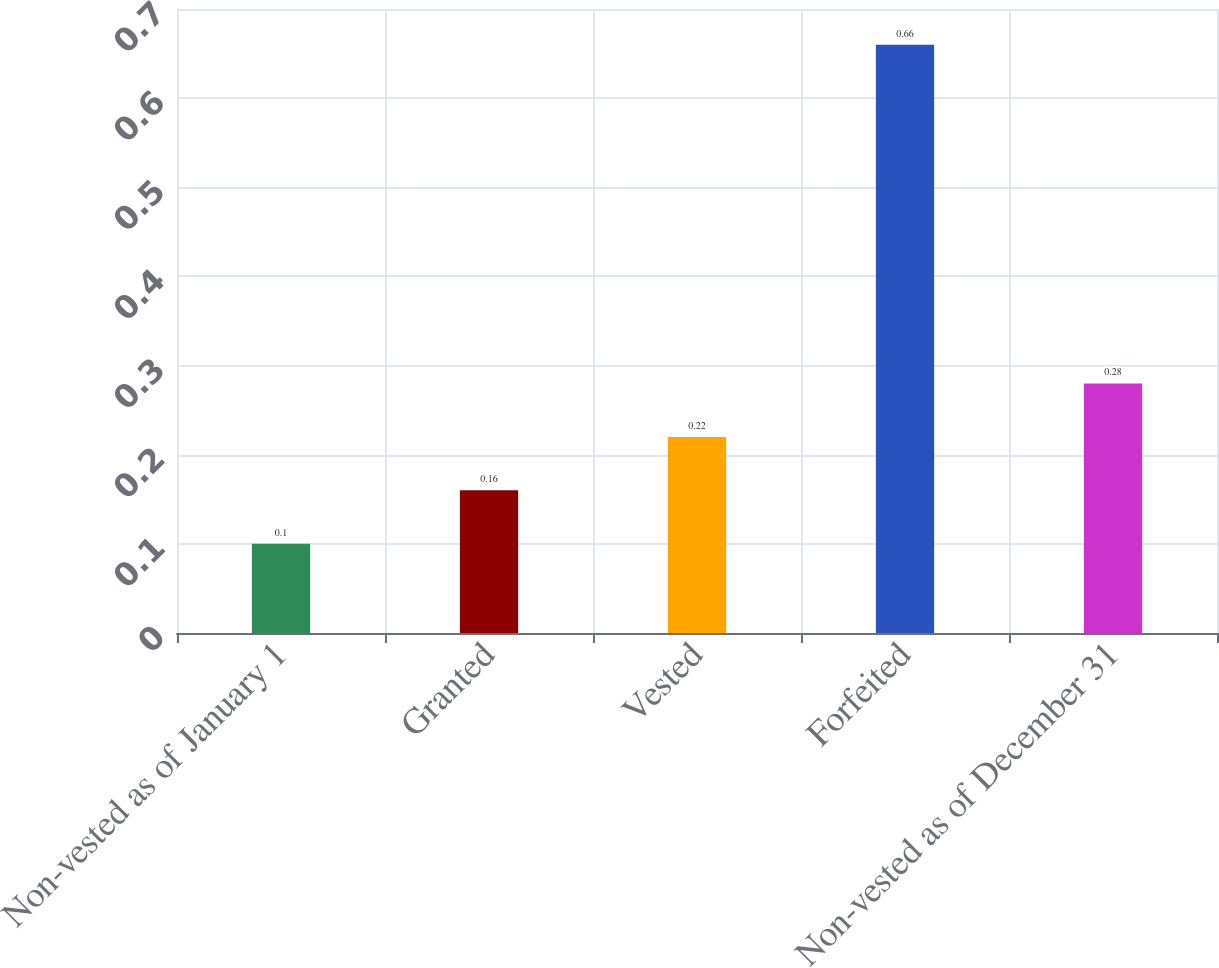Convert chart to OTSL. <chart><loc_0><loc_0><loc_500><loc_500><bar_chart><fcel>Non-vested as of January 1<fcel>Granted<fcel>Vested<fcel>Forfeited<fcel>Non-vested as of December 31<nl><fcel>0.1<fcel>0.16<fcel>0.22<fcel>0.66<fcel>0.28<nl></chart> 